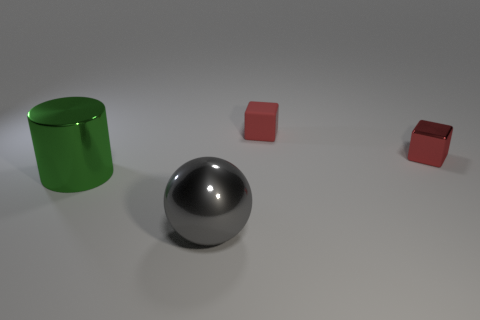Add 3 cylinders. How many objects exist? 7 Subtract 1 blocks. How many blocks are left? 1 Add 3 large cylinders. How many large cylinders exist? 4 Subtract 0 blue balls. How many objects are left? 4 Subtract all cylinders. How many objects are left? 3 Subtract all blue blocks. Subtract all red balls. How many blocks are left? 2 Subtract all red cubes. How many brown cylinders are left? 0 Subtract all tiny blue metallic spheres. Subtract all tiny red blocks. How many objects are left? 2 Add 1 big green metallic objects. How many big green metallic objects are left? 2 